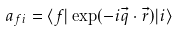<formula> <loc_0><loc_0><loc_500><loc_500>a _ { f i } = \langle f | \exp ( - i \vec { q } \cdot \vec { r } ) | i \rangle</formula> 